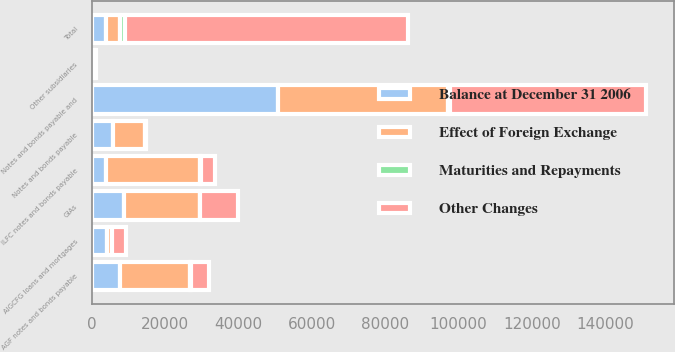Convert chart to OTSL. <chart><loc_0><loc_0><loc_500><loc_500><stacked_bar_chart><ecel><fcel>Notes and bonds payable<fcel>GIAs<fcel>Notes and bonds payable and<fcel>ILFC notes and bonds payable<fcel>AGF notes and bonds payable<fcel>AIGCFG loans and mortgages<fcel>Other subsidiaries<fcel>Total<nl><fcel>Effect of Foreign Exchange<fcel>8915<fcel>20664<fcel>46384<fcel>25592<fcel>19261<fcel>1453<fcel>672<fcel>3860.5<nl><fcel>Balance at December 31 2006<fcel>5591<fcel>8830<fcel>50854<fcel>3783<fcel>7481<fcel>3941<fcel>189<fcel>3860.5<nl><fcel>Other Changes<fcel>165<fcel>10172<fcel>53540<fcel>3938<fcel>4824<fcel>3647<fcel>189<fcel>77218<nl><fcel>Maturities and Repayments<fcel>122<fcel>43<fcel>321<fcel>295<fcel>255<fcel>98<fcel>3<fcel>1372<nl></chart> 